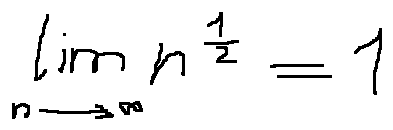<formula> <loc_0><loc_0><loc_500><loc_500>\lim \lim i t s _ { n \rightarrow \infty } n ^ { \frac { 1 } { 2 } } = 1</formula> 